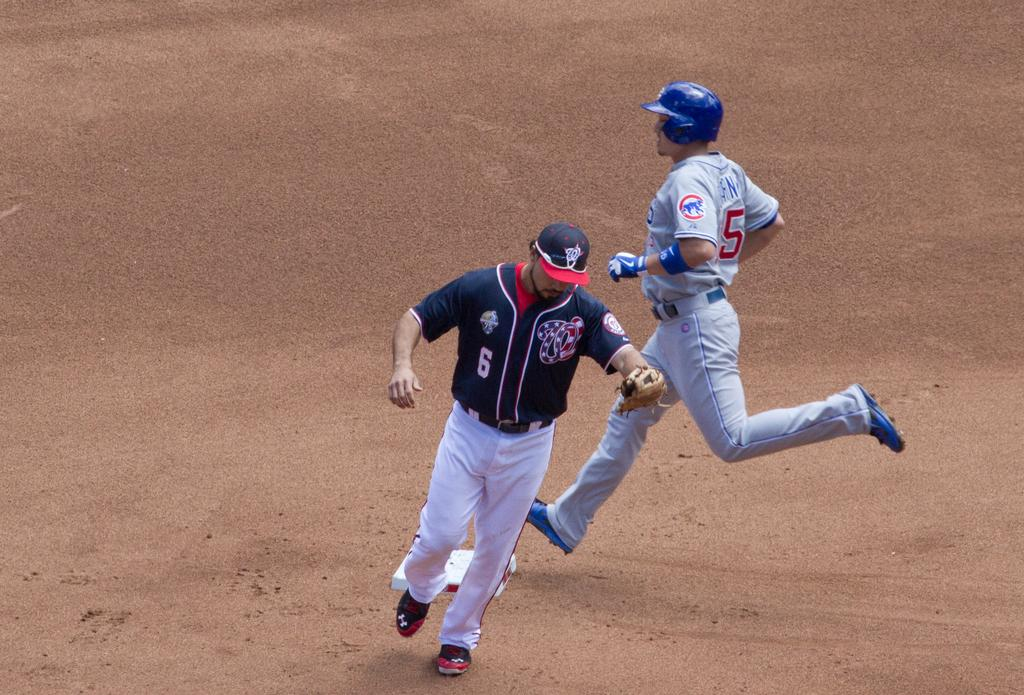Who or what can be seen in the image? There are people in the image. Can you describe the clothing of the people in the image? The people are wearing different color dresses. What type of surface is visible in the image? There is sand visible in the image. What type of clock can be seen in the image? There is no clock present in the image. Can you tell me which animals are in the zoo in the image? There is no zoo or animals present in the image. 